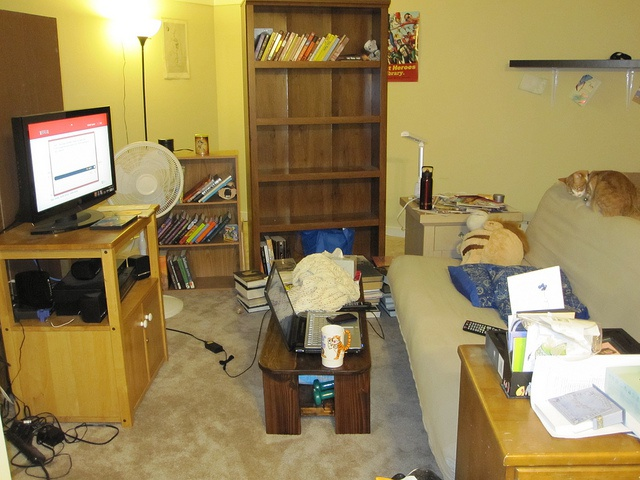Describe the objects in this image and their specific colors. I can see couch in tan and gray tones, tv in tan, white, black, maroon, and salmon tones, book in tan, black, and gray tones, laptop in tan, black, gray, and darkgray tones, and teddy bear in tan, olive, and maroon tones in this image. 